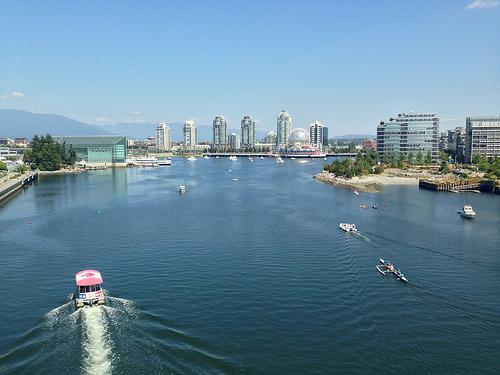List five objects that you can see in the image. Boats in the water, mountains in the distance, buildings along the shore, trees beside the water, and water ripples. Briefly describe the scene involving the people sitting in the long row boat. A group of people are sitting in a long row boat, possibly rowing in a kayak, with water ripples surrounding them. Mention a notable feature of the boat with the pink canopy. The boat with the pink canopy has a distinct symbol on top of it. Where can one find the globular building in the image? The globular building is located on the shore, close to other buildings and trees. Identify an instance of a boat and its surroundings in the image. A boat with a red top can be seen in the water, with white water behind it and water ripples around it. What is the primary setting of the image? A city landscape with a body of water and boats, buildings, and nature elements. What type of natural elements can be seen in the image? Mountains, trees, set of trees on shore, shrubbery beside the water, and body of water with ripples. List three different types of buildings in the image. Tall building in the distance, building with many windows, and short tan building located near the middle line-up of buildings. Describe the sky in the image. The sky is blue and clear with no clouds, and appears above the buildings and mountains. Which part of the water body do the boating dock and protruding deck appear? The boating dock and protruding deck appear near the water on the right side of the image. 